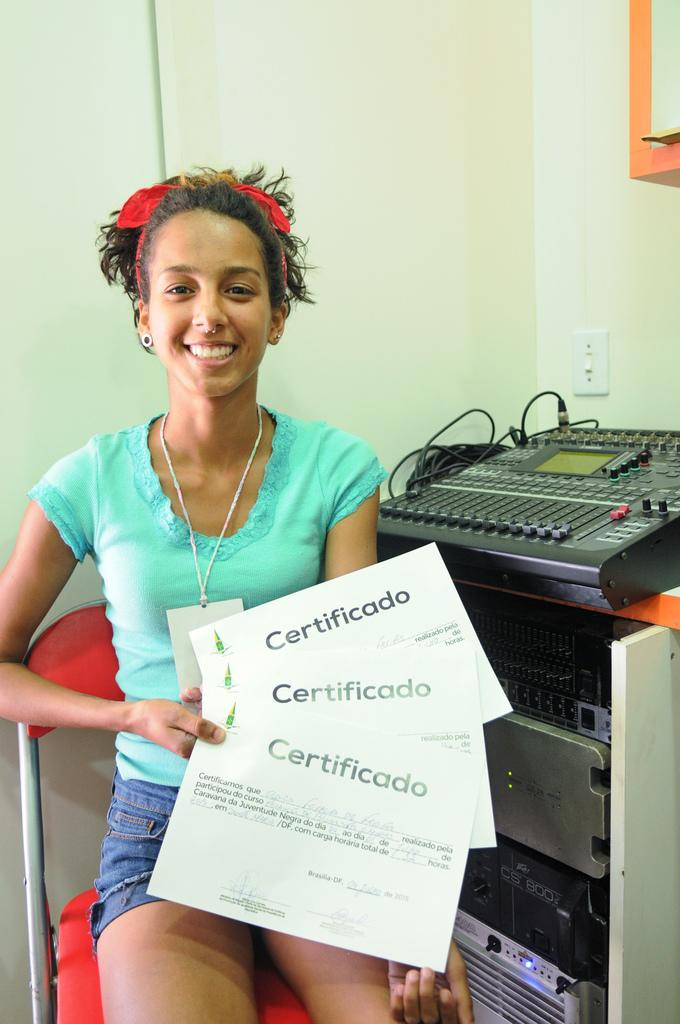What is the person in the image doing? The person is sitting on a chair and holding cards. What else can be seen in the image besides the person? There are electronic devices visible in the image. What is the background of the image? There is a wall in the image. What type of rail can be seen in the image? There is no rail present in the image. What place is the person in the image taking care of? The image does not provide information about the person taking care of a place. 